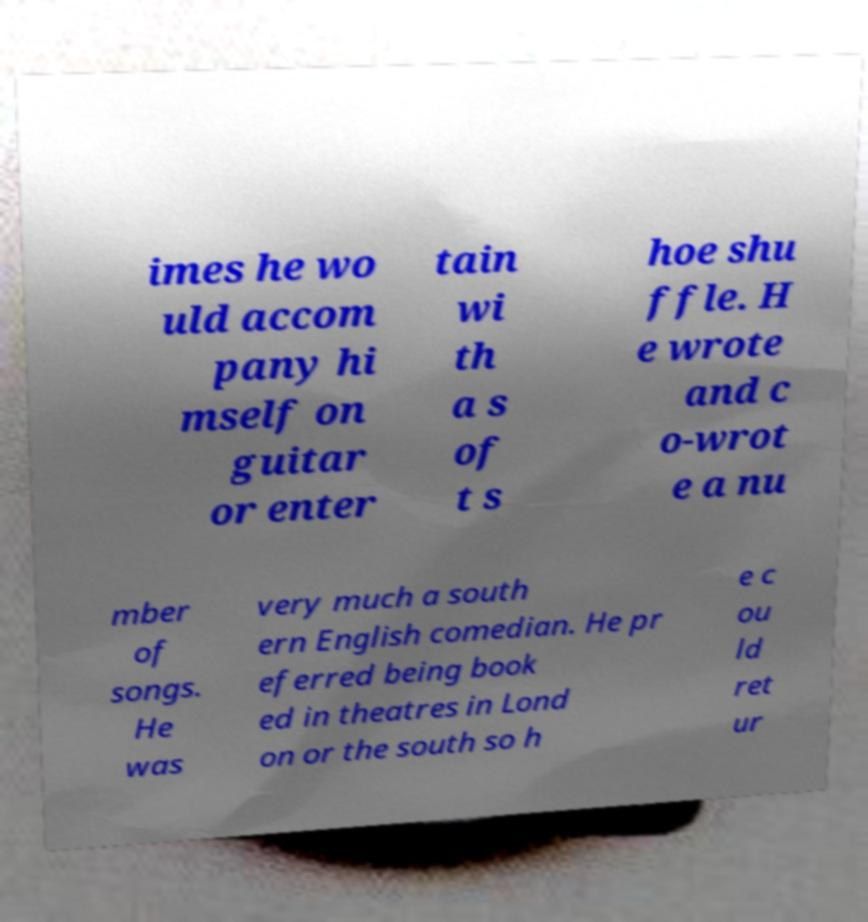What messages or text are displayed in this image? I need them in a readable, typed format. imes he wo uld accom pany hi mself on guitar or enter tain wi th a s of t s hoe shu ffle. H e wrote and c o-wrot e a nu mber of songs. He was very much a south ern English comedian. He pr eferred being book ed in theatres in Lond on or the south so h e c ou ld ret ur 